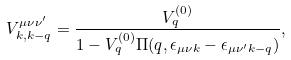Convert formula to latex. <formula><loc_0><loc_0><loc_500><loc_500>V ^ { \mu \nu \nu ^ { \prime } } _ { { k } , { k } - { q } } = \frac { V _ { q } ^ { ( 0 ) } } { { 1 - V _ { q } ^ { ( 0 ) } \Pi ( { q } , \epsilon _ { { \mu } \nu { k } } - \epsilon _ { { \mu } \nu ^ { \prime } { k } - { q } } ) } } ,</formula> 